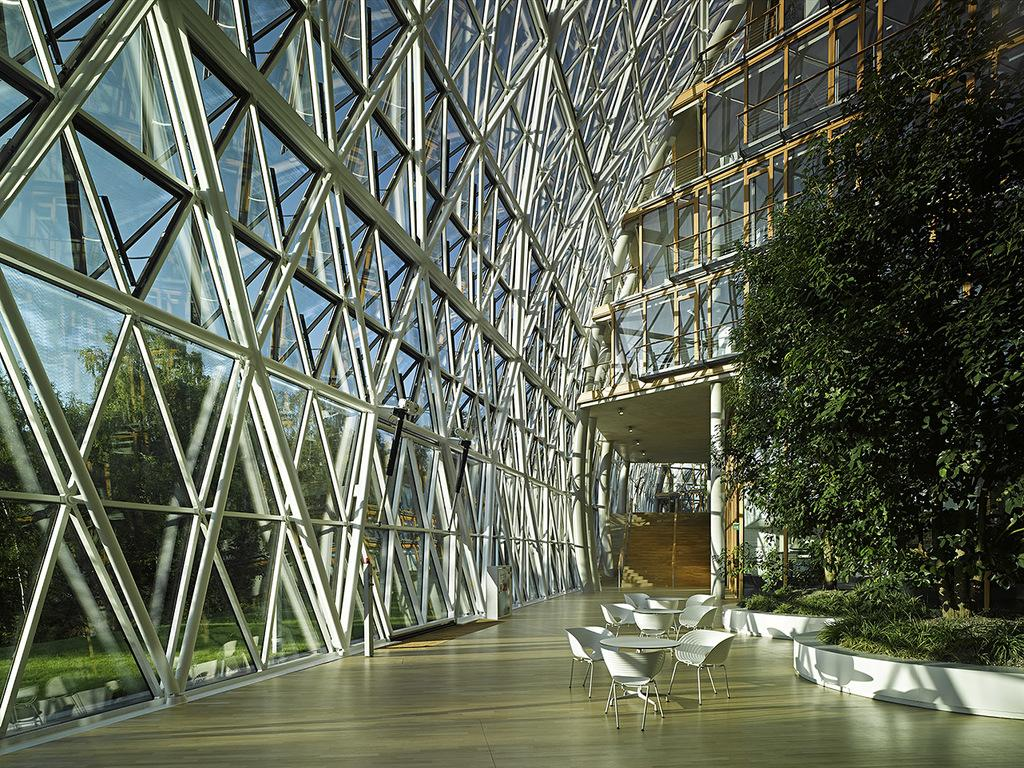What type of structure is visible in the image? There is a building in the image. What can be seen in the background of the image? There are trees in the background of the image. What type of furniture is present in the image? There are tables and chairs in the image. What color is the spark that is emitted from the thread in the image? There is no spark or thread present in the image. 